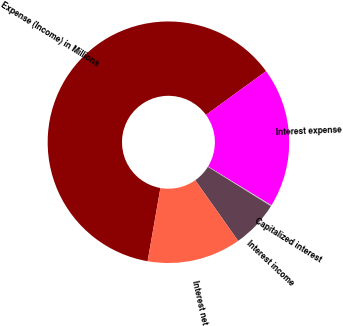Convert chart. <chart><loc_0><loc_0><loc_500><loc_500><pie_chart><fcel>Expense (Income) in Millions<fcel>Interest expense<fcel>Capitalized interest<fcel>Interest income<fcel>Interest net<nl><fcel>62.23%<fcel>18.76%<fcel>0.13%<fcel>6.34%<fcel>12.55%<nl></chart> 